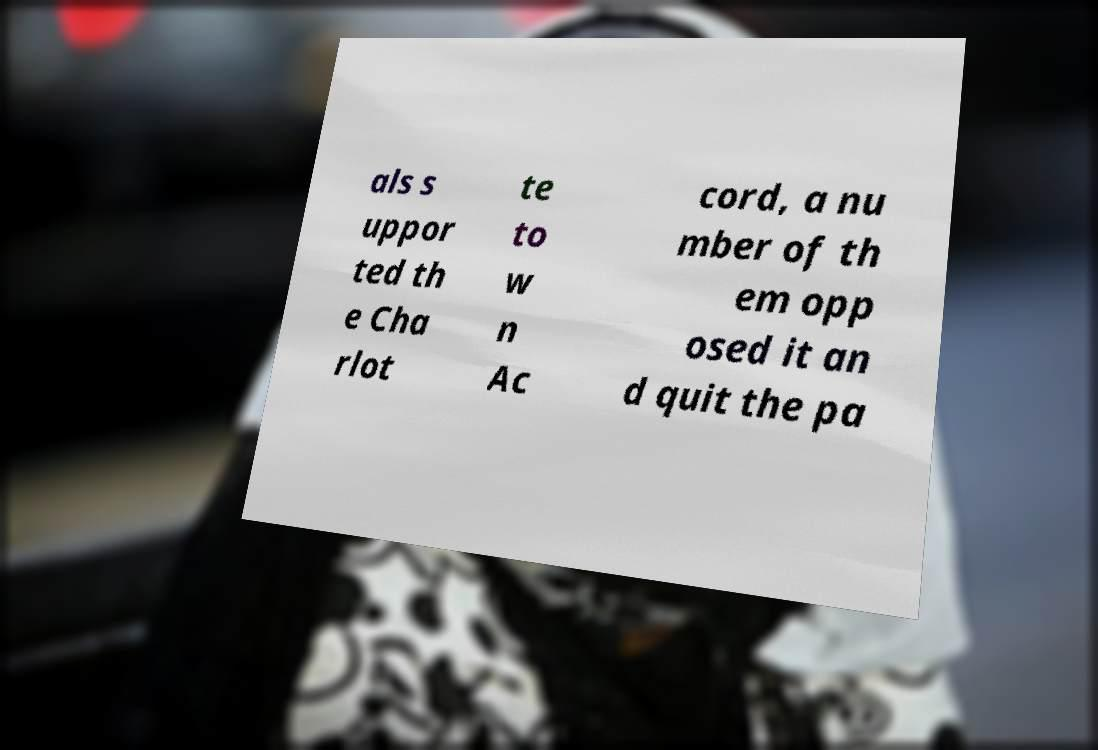I need the written content from this picture converted into text. Can you do that? als s uppor ted th e Cha rlot te to w n Ac cord, a nu mber of th em opp osed it an d quit the pa 